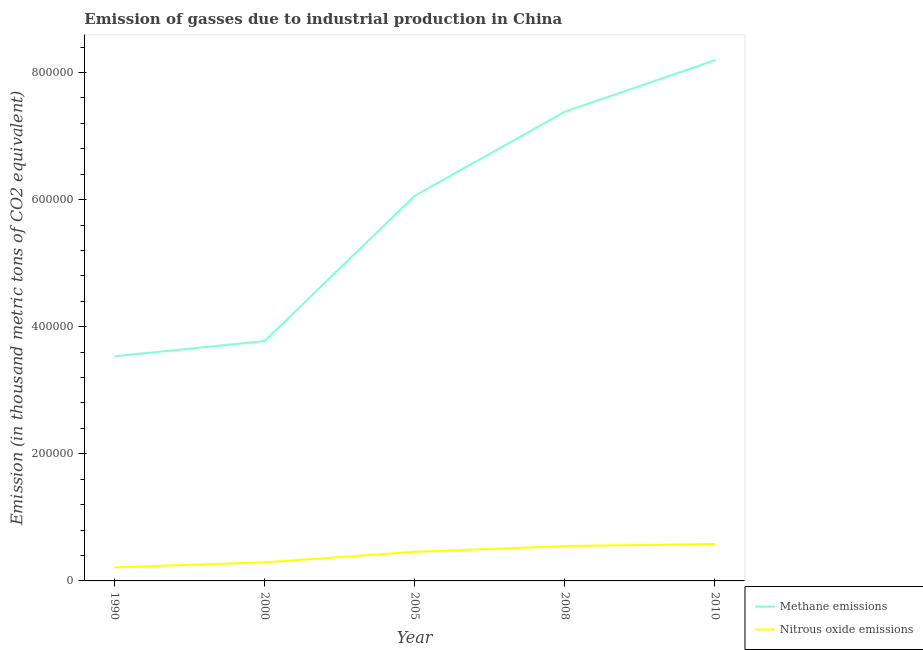How many different coloured lines are there?
Offer a terse response. 2. Does the line corresponding to amount of methane emissions intersect with the line corresponding to amount of nitrous oxide emissions?
Provide a short and direct response. No. Is the number of lines equal to the number of legend labels?
Offer a terse response. Yes. What is the amount of nitrous oxide emissions in 2010?
Offer a very short reply. 5.81e+04. Across all years, what is the maximum amount of methane emissions?
Your answer should be compact. 8.19e+05. Across all years, what is the minimum amount of methane emissions?
Offer a terse response. 3.54e+05. In which year was the amount of methane emissions minimum?
Provide a short and direct response. 1990. What is the total amount of nitrous oxide emissions in the graph?
Offer a terse response. 2.09e+05. What is the difference between the amount of nitrous oxide emissions in 1990 and that in 2010?
Offer a very short reply. -3.68e+04. What is the difference between the amount of methane emissions in 2005 and the amount of nitrous oxide emissions in 2000?
Ensure brevity in your answer.  5.77e+05. What is the average amount of nitrous oxide emissions per year?
Provide a succinct answer. 4.19e+04. In the year 2010, what is the difference between the amount of methane emissions and amount of nitrous oxide emissions?
Your answer should be very brief. 7.61e+05. What is the ratio of the amount of methane emissions in 2000 to that in 2010?
Ensure brevity in your answer.  0.46. What is the difference between the highest and the second highest amount of nitrous oxide emissions?
Ensure brevity in your answer.  3175.5. What is the difference between the highest and the lowest amount of nitrous oxide emissions?
Offer a terse response. 3.68e+04. In how many years, is the amount of methane emissions greater than the average amount of methane emissions taken over all years?
Give a very brief answer. 3. Is the amount of methane emissions strictly greater than the amount of nitrous oxide emissions over the years?
Offer a terse response. Yes. How many lines are there?
Your answer should be compact. 2. How many years are there in the graph?
Keep it short and to the point. 5. What is the difference between two consecutive major ticks on the Y-axis?
Provide a succinct answer. 2.00e+05. Are the values on the major ticks of Y-axis written in scientific E-notation?
Give a very brief answer. No. Does the graph contain grids?
Keep it short and to the point. No. Where does the legend appear in the graph?
Your answer should be compact. Bottom right. How are the legend labels stacked?
Your response must be concise. Vertical. What is the title of the graph?
Make the answer very short. Emission of gasses due to industrial production in China. What is the label or title of the X-axis?
Keep it short and to the point. Year. What is the label or title of the Y-axis?
Ensure brevity in your answer.  Emission (in thousand metric tons of CO2 equivalent). What is the Emission (in thousand metric tons of CO2 equivalent) in Methane emissions in 1990?
Your answer should be very brief. 3.54e+05. What is the Emission (in thousand metric tons of CO2 equivalent) in Nitrous oxide emissions in 1990?
Your answer should be compact. 2.13e+04. What is the Emission (in thousand metric tons of CO2 equivalent) of Methane emissions in 2000?
Provide a short and direct response. 3.77e+05. What is the Emission (in thousand metric tons of CO2 equivalent) in Nitrous oxide emissions in 2000?
Provide a short and direct response. 2.93e+04. What is the Emission (in thousand metric tons of CO2 equivalent) in Methane emissions in 2005?
Give a very brief answer. 6.06e+05. What is the Emission (in thousand metric tons of CO2 equivalent) in Nitrous oxide emissions in 2005?
Keep it short and to the point. 4.58e+04. What is the Emission (in thousand metric tons of CO2 equivalent) of Methane emissions in 2008?
Provide a short and direct response. 7.38e+05. What is the Emission (in thousand metric tons of CO2 equivalent) in Nitrous oxide emissions in 2008?
Ensure brevity in your answer.  5.49e+04. What is the Emission (in thousand metric tons of CO2 equivalent) in Methane emissions in 2010?
Provide a succinct answer. 8.19e+05. What is the Emission (in thousand metric tons of CO2 equivalent) in Nitrous oxide emissions in 2010?
Provide a short and direct response. 5.81e+04. Across all years, what is the maximum Emission (in thousand metric tons of CO2 equivalent) in Methane emissions?
Offer a very short reply. 8.19e+05. Across all years, what is the maximum Emission (in thousand metric tons of CO2 equivalent) of Nitrous oxide emissions?
Offer a very short reply. 5.81e+04. Across all years, what is the minimum Emission (in thousand metric tons of CO2 equivalent) in Methane emissions?
Your answer should be very brief. 3.54e+05. Across all years, what is the minimum Emission (in thousand metric tons of CO2 equivalent) in Nitrous oxide emissions?
Make the answer very short. 2.13e+04. What is the total Emission (in thousand metric tons of CO2 equivalent) of Methane emissions in the graph?
Make the answer very short. 2.89e+06. What is the total Emission (in thousand metric tons of CO2 equivalent) in Nitrous oxide emissions in the graph?
Give a very brief answer. 2.09e+05. What is the difference between the Emission (in thousand metric tons of CO2 equivalent) of Methane emissions in 1990 and that in 2000?
Give a very brief answer. -2.38e+04. What is the difference between the Emission (in thousand metric tons of CO2 equivalent) in Nitrous oxide emissions in 1990 and that in 2000?
Offer a terse response. -7984.9. What is the difference between the Emission (in thousand metric tons of CO2 equivalent) of Methane emissions in 1990 and that in 2005?
Your response must be concise. -2.53e+05. What is the difference between the Emission (in thousand metric tons of CO2 equivalent) of Nitrous oxide emissions in 1990 and that in 2005?
Make the answer very short. -2.45e+04. What is the difference between the Emission (in thousand metric tons of CO2 equivalent) of Methane emissions in 1990 and that in 2008?
Offer a very short reply. -3.85e+05. What is the difference between the Emission (in thousand metric tons of CO2 equivalent) in Nitrous oxide emissions in 1990 and that in 2008?
Give a very brief answer. -3.36e+04. What is the difference between the Emission (in thousand metric tons of CO2 equivalent) in Methane emissions in 1990 and that in 2010?
Your response must be concise. -4.66e+05. What is the difference between the Emission (in thousand metric tons of CO2 equivalent) of Nitrous oxide emissions in 1990 and that in 2010?
Your answer should be compact. -3.68e+04. What is the difference between the Emission (in thousand metric tons of CO2 equivalent) in Methane emissions in 2000 and that in 2005?
Your answer should be compact. -2.29e+05. What is the difference between the Emission (in thousand metric tons of CO2 equivalent) of Nitrous oxide emissions in 2000 and that in 2005?
Your response must be concise. -1.66e+04. What is the difference between the Emission (in thousand metric tons of CO2 equivalent) in Methane emissions in 2000 and that in 2008?
Offer a very short reply. -3.61e+05. What is the difference between the Emission (in thousand metric tons of CO2 equivalent) in Nitrous oxide emissions in 2000 and that in 2008?
Ensure brevity in your answer.  -2.56e+04. What is the difference between the Emission (in thousand metric tons of CO2 equivalent) in Methane emissions in 2000 and that in 2010?
Offer a terse response. -4.42e+05. What is the difference between the Emission (in thousand metric tons of CO2 equivalent) in Nitrous oxide emissions in 2000 and that in 2010?
Your response must be concise. -2.88e+04. What is the difference between the Emission (in thousand metric tons of CO2 equivalent) of Methane emissions in 2005 and that in 2008?
Your response must be concise. -1.32e+05. What is the difference between the Emission (in thousand metric tons of CO2 equivalent) of Nitrous oxide emissions in 2005 and that in 2008?
Ensure brevity in your answer.  -9056.8. What is the difference between the Emission (in thousand metric tons of CO2 equivalent) in Methane emissions in 2005 and that in 2010?
Your response must be concise. -2.13e+05. What is the difference between the Emission (in thousand metric tons of CO2 equivalent) of Nitrous oxide emissions in 2005 and that in 2010?
Your response must be concise. -1.22e+04. What is the difference between the Emission (in thousand metric tons of CO2 equivalent) in Methane emissions in 2008 and that in 2010?
Your response must be concise. -8.10e+04. What is the difference between the Emission (in thousand metric tons of CO2 equivalent) of Nitrous oxide emissions in 2008 and that in 2010?
Make the answer very short. -3175.5. What is the difference between the Emission (in thousand metric tons of CO2 equivalent) of Methane emissions in 1990 and the Emission (in thousand metric tons of CO2 equivalent) of Nitrous oxide emissions in 2000?
Offer a terse response. 3.24e+05. What is the difference between the Emission (in thousand metric tons of CO2 equivalent) of Methane emissions in 1990 and the Emission (in thousand metric tons of CO2 equivalent) of Nitrous oxide emissions in 2005?
Offer a terse response. 3.08e+05. What is the difference between the Emission (in thousand metric tons of CO2 equivalent) of Methane emissions in 1990 and the Emission (in thousand metric tons of CO2 equivalent) of Nitrous oxide emissions in 2008?
Ensure brevity in your answer.  2.99e+05. What is the difference between the Emission (in thousand metric tons of CO2 equivalent) of Methane emissions in 1990 and the Emission (in thousand metric tons of CO2 equivalent) of Nitrous oxide emissions in 2010?
Offer a terse response. 2.95e+05. What is the difference between the Emission (in thousand metric tons of CO2 equivalent) of Methane emissions in 2000 and the Emission (in thousand metric tons of CO2 equivalent) of Nitrous oxide emissions in 2005?
Provide a short and direct response. 3.31e+05. What is the difference between the Emission (in thousand metric tons of CO2 equivalent) of Methane emissions in 2000 and the Emission (in thousand metric tons of CO2 equivalent) of Nitrous oxide emissions in 2008?
Ensure brevity in your answer.  3.22e+05. What is the difference between the Emission (in thousand metric tons of CO2 equivalent) of Methane emissions in 2000 and the Emission (in thousand metric tons of CO2 equivalent) of Nitrous oxide emissions in 2010?
Keep it short and to the point. 3.19e+05. What is the difference between the Emission (in thousand metric tons of CO2 equivalent) in Methane emissions in 2005 and the Emission (in thousand metric tons of CO2 equivalent) in Nitrous oxide emissions in 2008?
Your response must be concise. 5.51e+05. What is the difference between the Emission (in thousand metric tons of CO2 equivalent) in Methane emissions in 2005 and the Emission (in thousand metric tons of CO2 equivalent) in Nitrous oxide emissions in 2010?
Your answer should be compact. 5.48e+05. What is the difference between the Emission (in thousand metric tons of CO2 equivalent) in Methane emissions in 2008 and the Emission (in thousand metric tons of CO2 equivalent) in Nitrous oxide emissions in 2010?
Ensure brevity in your answer.  6.80e+05. What is the average Emission (in thousand metric tons of CO2 equivalent) in Methane emissions per year?
Your response must be concise. 5.79e+05. What is the average Emission (in thousand metric tons of CO2 equivalent) of Nitrous oxide emissions per year?
Make the answer very short. 4.19e+04. In the year 1990, what is the difference between the Emission (in thousand metric tons of CO2 equivalent) of Methane emissions and Emission (in thousand metric tons of CO2 equivalent) of Nitrous oxide emissions?
Make the answer very short. 3.32e+05. In the year 2000, what is the difference between the Emission (in thousand metric tons of CO2 equivalent) in Methane emissions and Emission (in thousand metric tons of CO2 equivalent) in Nitrous oxide emissions?
Make the answer very short. 3.48e+05. In the year 2005, what is the difference between the Emission (in thousand metric tons of CO2 equivalent) in Methane emissions and Emission (in thousand metric tons of CO2 equivalent) in Nitrous oxide emissions?
Your answer should be compact. 5.60e+05. In the year 2008, what is the difference between the Emission (in thousand metric tons of CO2 equivalent) in Methane emissions and Emission (in thousand metric tons of CO2 equivalent) in Nitrous oxide emissions?
Ensure brevity in your answer.  6.83e+05. In the year 2010, what is the difference between the Emission (in thousand metric tons of CO2 equivalent) in Methane emissions and Emission (in thousand metric tons of CO2 equivalent) in Nitrous oxide emissions?
Your answer should be very brief. 7.61e+05. What is the ratio of the Emission (in thousand metric tons of CO2 equivalent) in Methane emissions in 1990 to that in 2000?
Your response must be concise. 0.94. What is the ratio of the Emission (in thousand metric tons of CO2 equivalent) in Nitrous oxide emissions in 1990 to that in 2000?
Give a very brief answer. 0.73. What is the ratio of the Emission (in thousand metric tons of CO2 equivalent) of Methane emissions in 1990 to that in 2005?
Make the answer very short. 0.58. What is the ratio of the Emission (in thousand metric tons of CO2 equivalent) in Nitrous oxide emissions in 1990 to that in 2005?
Ensure brevity in your answer.  0.46. What is the ratio of the Emission (in thousand metric tons of CO2 equivalent) of Methane emissions in 1990 to that in 2008?
Make the answer very short. 0.48. What is the ratio of the Emission (in thousand metric tons of CO2 equivalent) in Nitrous oxide emissions in 1990 to that in 2008?
Give a very brief answer. 0.39. What is the ratio of the Emission (in thousand metric tons of CO2 equivalent) of Methane emissions in 1990 to that in 2010?
Keep it short and to the point. 0.43. What is the ratio of the Emission (in thousand metric tons of CO2 equivalent) in Nitrous oxide emissions in 1990 to that in 2010?
Offer a terse response. 0.37. What is the ratio of the Emission (in thousand metric tons of CO2 equivalent) of Methane emissions in 2000 to that in 2005?
Your answer should be compact. 0.62. What is the ratio of the Emission (in thousand metric tons of CO2 equivalent) of Nitrous oxide emissions in 2000 to that in 2005?
Ensure brevity in your answer.  0.64. What is the ratio of the Emission (in thousand metric tons of CO2 equivalent) in Methane emissions in 2000 to that in 2008?
Your response must be concise. 0.51. What is the ratio of the Emission (in thousand metric tons of CO2 equivalent) of Nitrous oxide emissions in 2000 to that in 2008?
Offer a very short reply. 0.53. What is the ratio of the Emission (in thousand metric tons of CO2 equivalent) of Methane emissions in 2000 to that in 2010?
Give a very brief answer. 0.46. What is the ratio of the Emission (in thousand metric tons of CO2 equivalent) in Nitrous oxide emissions in 2000 to that in 2010?
Offer a terse response. 0.5. What is the ratio of the Emission (in thousand metric tons of CO2 equivalent) of Methane emissions in 2005 to that in 2008?
Give a very brief answer. 0.82. What is the ratio of the Emission (in thousand metric tons of CO2 equivalent) of Nitrous oxide emissions in 2005 to that in 2008?
Provide a succinct answer. 0.83. What is the ratio of the Emission (in thousand metric tons of CO2 equivalent) in Methane emissions in 2005 to that in 2010?
Your answer should be compact. 0.74. What is the ratio of the Emission (in thousand metric tons of CO2 equivalent) of Nitrous oxide emissions in 2005 to that in 2010?
Your response must be concise. 0.79. What is the ratio of the Emission (in thousand metric tons of CO2 equivalent) of Methane emissions in 2008 to that in 2010?
Offer a very short reply. 0.9. What is the ratio of the Emission (in thousand metric tons of CO2 equivalent) in Nitrous oxide emissions in 2008 to that in 2010?
Your answer should be compact. 0.95. What is the difference between the highest and the second highest Emission (in thousand metric tons of CO2 equivalent) in Methane emissions?
Your answer should be very brief. 8.10e+04. What is the difference between the highest and the second highest Emission (in thousand metric tons of CO2 equivalent) in Nitrous oxide emissions?
Make the answer very short. 3175.5. What is the difference between the highest and the lowest Emission (in thousand metric tons of CO2 equivalent) in Methane emissions?
Your response must be concise. 4.66e+05. What is the difference between the highest and the lowest Emission (in thousand metric tons of CO2 equivalent) in Nitrous oxide emissions?
Offer a very short reply. 3.68e+04. 